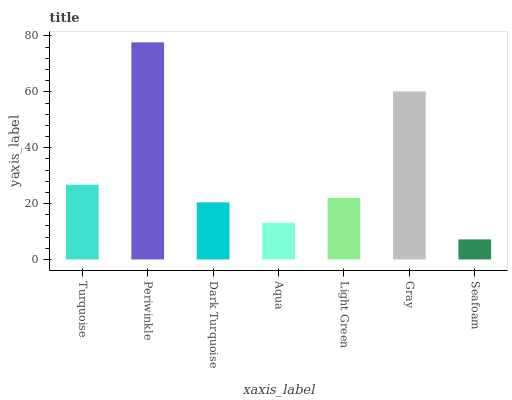Is Seafoam the minimum?
Answer yes or no. Yes. Is Periwinkle the maximum?
Answer yes or no. Yes. Is Dark Turquoise the minimum?
Answer yes or no. No. Is Dark Turquoise the maximum?
Answer yes or no. No. Is Periwinkle greater than Dark Turquoise?
Answer yes or no. Yes. Is Dark Turquoise less than Periwinkle?
Answer yes or no. Yes. Is Dark Turquoise greater than Periwinkle?
Answer yes or no. No. Is Periwinkle less than Dark Turquoise?
Answer yes or no. No. Is Light Green the high median?
Answer yes or no. Yes. Is Light Green the low median?
Answer yes or no. Yes. Is Periwinkle the high median?
Answer yes or no. No. Is Seafoam the low median?
Answer yes or no. No. 